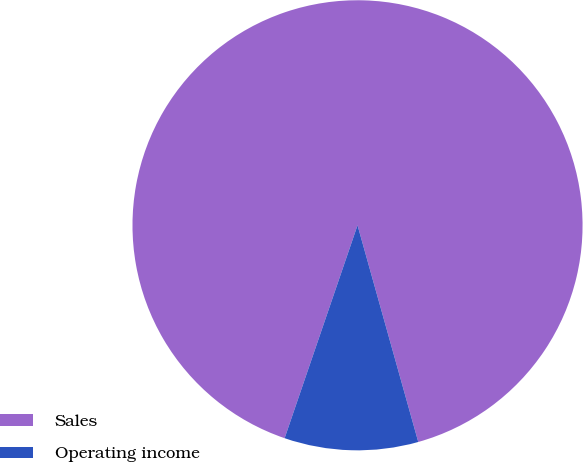Convert chart. <chart><loc_0><loc_0><loc_500><loc_500><pie_chart><fcel>Sales<fcel>Operating income<nl><fcel>90.4%<fcel>9.6%<nl></chart> 